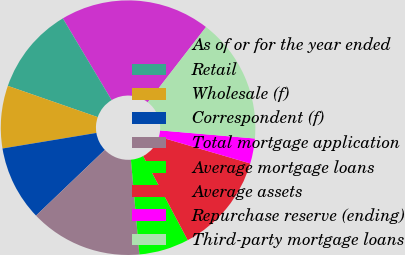Convert chart. <chart><loc_0><loc_0><loc_500><loc_500><pie_chart><fcel>As of or for the year ended<fcel>Retail<fcel>Wholesale (f)<fcel>Correspondent (f)<fcel>Total mortgage application<fcel>Average mortgage loans<fcel>Average assets<fcel>Repurchase reserve (ending)<fcel>Third-party mortgage loans<nl><fcel>19.05%<fcel>11.11%<fcel>7.94%<fcel>9.52%<fcel>14.28%<fcel>6.35%<fcel>12.7%<fcel>3.18%<fcel>15.87%<nl></chart> 